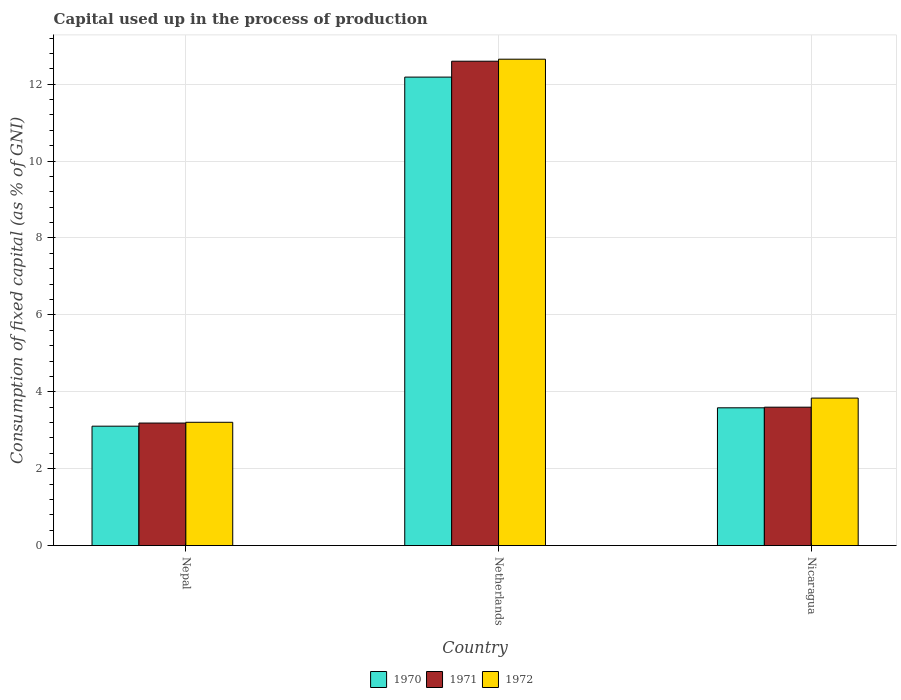How many different coloured bars are there?
Your answer should be compact. 3. How many bars are there on the 3rd tick from the left?
Ensure brevity in your answer.  3. How many bars are there on the 3rd tick from the right?
Provide a succinct answer. 3. What is the label of the 3rd group of bars from the left?
Offer a terse response. Nicaragua. What is the capital used up in the process of production in 1971 in Nicaragua?
Offer a very short reply. 3.6. Across all countries, what is the maximum capital used up in the process of production in 1971?
Make the answer very short. 12.6. Across all countries, what is the minimum capital used up in the process of production in 1971?
Your response must be concise. 3.19. In which country was the capital used up in the process of production in 1972 minimum?
Your answer should be compact. Nepal. What is the total capital used up in the process of production in 1970 in the graph?
Ensure brevity in your answer.  18.87. What is the difference between the capital used up in the process of production in 1971 in Netherlands and that in Nicaragua?
Make the answer very short. 9. What is the difference between the capital used up in the process of production in 1970 in Nepal and the capital used up in the process of production in 1971 in Netherlands?
Ensure brevity in your answer.  -9.49. What is the average capital used up in the process of production in 1971 per country?
Offer a terse response. 6.46. What is the difference between the capital used up in the process of production of/in 1970 and capital used up in the process of production of/in 1971 in Nicaragua?
Your response must be concise. -0.02. What is the ratio of the capital used up in the process of production in 1970 in Netherlands to that in Nicaragua?
Give a very brief answer. 3.4. Is the capital used up in the process of production in 1970 in Netherlands less than that in Nicaragua?
Offer a very short reply. No. Is the difference between the capital used up in the process of production in 1970 in Nepal and Netherlands greater than the difference between the capital used up in the process of production in 1971 in Nepal and Netherlands?
Make the answer very short. Yes. What is the difference between the highest and the second highest capital used up in the process of production in 1972?
Offer a terse response. -0.63. What is the difference between the highest and the lowest capital used up in the process of production in 1971?
Your answer should be very brief. 9.41. In how many countries, is the capital used up in the process of production in 1970 greater than the average capital used up in the process of production in 1970 taken over all countries?
Your answer should be very brief. 1. Is it the case that in every country, the sum of the capital used up in the process of production in 1971 and capital used up in the process of production in 1970 is greater than the capital used up in the process of production in 1972?
Ensure brevity in your answer.  Yes. Are all the bars in the graph horizontal?
Provide a succinct answer. No. How many countries are there in the graph?
Keep it short and to the point. 3. What is the difference between two consecutive major ticks on the Y-axis?
Keep it short and to the point. 2. How many legend labels are there?
Give a very brief answer. 3. What is the title of the graph?
Your answer should be very brief. Capital used up in the process of production. Does "2013" appear as one of the legend labels in the graph?
Provide a short and direct response. No. What is the label or title of the Y-axis?
Your response must be concise. Consumption of fixed capital (as % of GNI). What is the Consumption of fixed capital (as % of GNI) in 1970 in Nepal?
Ensure brevity in your answer.  3.1. What is the Consumption of fixed capital (as % of GNI) in 1971 in Nepal?
Make the answer very short. 3.19. What is the Consumption of fixed capital (as % of GNI) in 1972 in Nepal?
Your response must be concise. 3.21. What is the Consumption of fixed capital (as % of GNI) in 1970 in Netherlands?
Offer a very short reply. 12.18. What is the Consumption of fixed capital (as % of GNI) of 1971 in Netherlands?
Make the answer very short. 12.6. What is the Consumption of fixed capital (as % of GNI) in 1972 in Netherlands?
Ensure brevity in your answer.  12.65. What is the Consumption of fixed capital (as % of GNI) of 1970 in Nicaragua?
Provide a short and direct response. 3.58. What is the Consumption of fixed capital (as % of GNI) of 1971 in Nicaragua?
Provide a succinct answer. 3.6. What is the Consumption of fixed capital (as % of GNI) in 1972 in Nicaragua?
Your answer should be very brief. 3.84. Across all countries, what is the maximum Consumption of fixed capital (as % of GNI) in 1970?
Offer a very short reply. 12.18. Across all countries, what is the maximum Consumption of fixed capital (as % of GNI) of 1971?
Provide a succinct answer. 12.6. Across all countries, what is the maximum Consumption of fixed capital (as % of GNI) of 1972?
Provide a short and direct response. 12.65. Across all countries, what is the minimum Consumption of fixed capital (as % of GNI) in 1970?
Provide a short and direct response. 3.1. Across all countries, what is the minimum Consumption of fixed capital (as % of GNI) of 1971?
Ensure brevity in your answer.  3.19. Across all countries, what is the minimum Consumption of fixed capital (as % of GNI) of 1972?
Offer a terse response. 3.21. What is the total Consumption of fixed capital (as % of GNI) of 1970 in the graph?
Provide a short and direct response. 18.87. What is the total Consumption of fixed capital (as % of GNI) in 1971 in the graph?
Your response must be concise. 19.38. What is the total Consumption of fixed capital (as % of GNI) of 1972 in the graph?
Offer a terse response. 19.69. What is the difference between the Consumption of fixed capital (as % of GNI) in 1970 in Nepal and that in Netherlands?
Provide a short and direct response. -9.08. What is the difference between the Consumption of fixed capital (as % of GNI) in 1971 in Nepal and that in Netherlands?
Offer a very short reply. -9.41. What is the difference between the Consumption of fixed capital (as % of GNI) of 1972 in Nepal and that in Netherlands?
Your answer should be compact. -9.44. What is the difference between the Consumption of fixed capital (as % of GNI) in 1970 in Nepal and that in Nicaragua?
Make the answer very short. -0.48. What is the difference between the Consumption of fixed capital (as % of GNI) of 1971 in Nepal and that in Nicaragua?
Keep it short and to the point. -0.41. What is the difference between the Consumption of fixed capital (as % of GNI) in 1972 in Nepal and that in Nicaragua?
Your response must be concise. -0.63. What is the difference between the Consumption of fixed capital (as % of GNI) in 1970 in Netherlands and that in Nicaragua?
Offer a terse response. 8.6. What is the difference between the Consumption of fixed capital (as % of GNI) in 1971 in Netherlands and that in Nicaragua?
Your answer should be compact. 9. What is the difference between the Consumption of fixed capital (as % of GNI) in 1972 in Netherlands and that in Nicaragua?
Your answer should be very brief. 8.81. What is the difference between the Consumption of fixed capital (as % of GNI) in 1970 in Nepal and the Consumption of fixed capital (as % of GNI) in 1971 in Netherlands?
Provide a short and direct response. -9.49. What is the difference between the Consumption of fixed capital (as % of GNI) in 1970 in Nepal and the Consumption of fixed capital (as % of GNI) in 1972 in Netherlands?
Make the answer very short. -9.54. What is the difference between the Consumption of fixed capital (as % of GNI) of 1971 in Nepal and the Consumption of fixed capital (as % of GNI) of 1972 in Netherlands?
Give a very brief answer. -9.46. What is the difference between the Consumption of fixed capital (as % of GNI) of 1970 in Nepal and the Consumption of fixed capital (as % of GNI) of 1971 in Nicaragua?
Provide a succinct answer. -0.49. What is the difference between the Consumption of fixed capital (as % of GNI) of 1970 in Nepal and the Consumption of fixed capital (as % of GNI) of 1972 in Nicaragua?
Ensure brevity in your answer.  -0.73. What is the difference between the Consumption of fixed capital (as % of GNI) in 1971 in Nepal and the Consumption of fixed capital (as % of GNI) in 1972 in Nicaragua?
Offer a terse response. -0.65. What is the difference between the Consumption of fixed capital (as % of GNI) in 1970 in Netherlands and the Consumption of fixed capital (as % of GNI) in 1971 in Nicaragua?
Offer a terse response. 8.58. What is the difference between the Consumption of fixed capital (as % of GNI) of 1970 in Netherlands and the Consumption of fixed capital (as % of GNI) of 1972 in Nicaragua?
Ensure brevity in your answer.  8.35. What is the difference between the Consumption of fixed capital (as % of GNI) of 1971 in Netherlands and the Consumption of fixed capital (as % of GNI) of 1972 in Nicaragua?
Keep it short and to the point. 8.76. What is the average Consumption of fixed capital (as % of GNI) in 1970 per country?
Make the answer very short. 6.29. What is the average Consumption of fixed capital (as % of GNI) in 1971 per country?
Your response must be concise. 6.46. What is the average Consumption of fixed capital (as % of GNI) in 1972 per country?
Offer a very short reply. 6.56. What is the difference between the Consumption of fixed capital (as % of GNI) of 1970 and Consumption of fixed capital (as % of GNI) of 1971 in Nepal?
Your answer should be compact. -0.08. What is the difference between the Consumption of fixed capital (as % of GNI) of 1970 and Consumption of fixed capital (as % of GNI) of 1972 in Nepal?
Your answer should be very brief. -0.1. What is the difference between the Consumption of fixed capital (as % of GNI) in 1971 and Consumption of fixed capital (as % of GNI) in 1972 in Nepal?
Provide a short and direct response. -0.02. What is the difference between the Consumption of fixed capital (as % of GNI) of 1970 and Consumption of fixed capital (as % of GNI) of 1971 in Netherlands?
Your answer should be very brief. -0.41. What is the difference between the Consumption of fixed capital (as % of GNI) in 1970 and Consumption of fixed capital (as % of GNI) in 1972 in Netherlands?
Your response must be concise. -0.47. What is the difference between the Consumption of fixed capital (as % of GNI) in 1971 and Consumption of fixed capital (as % of GNI) in 1972 in Netherlands?
Your answer should be compact. -0.05. What is the difference between the Consumption of fixed capital (as % of GNI) in 1970 and Consumption of fixed capital (as % of GNI) in 1971 in Nicaragua?
Keep it short and to the point. -0.02. What is the difference between the Consumption of fixed capital (as % of GNI) in 1970 and Consumption of fixed capital (as % of GNI) in 1972 in Nicaragua?
Provide a short and direct response. -0.25. What is the difference between the Consumption of fixed capital (as % of GNI) in 1971 and Consumption of fixed capital (as % of GNI) in 1972 in Nicaragua?
Your response must be concise. -0.24. What is the ratio of the Consumption of fixed capital (as % of GNI) in 1970 in Nepal to that in Netherlands?
Provide a succinct answer. 0.25. What is the ratio of the Consumption of fixed capital (as % of GNI) in 1971 in Nepal to that in Netherlands?
Ensure brevity in your answer.  0.25. What is the ratio of the Consumption of fixed capital (as % of GNI) in 1972 in Nepal to that in Netherlands?
Keep it short and to the point. 0.25. What is the ratio of the Consumption of fixed capital (as % of GNI) in 1970 in Nepal to that in Nicaragua?
Make the answer very short. 0.87. What is the ratio of the Consumption of fixed capital (as % of GNI) of 1971 in Nepal to that in Nicaragua?
Provide a short and direct response. 0.89. What is the ratio of the Consumption of fixed capital (as % of GNI) of 1972 in Nepal to that in Nicaragua?
Ensure brevity in your answer.  0.84. What is the ratio of the Consumption of fixed capital (as % of GNI) in 1970 in Netherlands to that in Nicaragua?
Provide a succinct answer. 3.4. What is the ratio of the Consumption of fixed capital (as % of GNI) of 1971 in Netherlands to that in Nicaragua?
Give a very brief answer. 3.5. What is the ratio of the Consumption of fixed capital (as % of GNI) in 1972 in Netherlands to that in Nicaragua?
Provide a short and direct response. 3.3. What is the difference between the highest and the second highest Consumption of fixed capital (as % of GNI) in 1970?
Keep it short and to the point. 8.6. What is the difference between the highest and the second highest Consumption of fixed capital (as % of GNI) in 1971?
Make the answer very short. 9. What is the difference between the highest and the second highest Consumption of fixed capital (as % of GNI) of 1972?
Provide a short and direct response. 8.81. What is the difference between the highest and the lowest Consumption of fixed capital (as % of GNI) of 1970?
Provide a short and direct response. 9.08. What is the difference between the highest and the lowest Consumption of fixed capital (as % of GNI) in 1971?
Ensure brevity in your answer.  9.41. What is the difference between the highest and the lowest Consumption of fixed capital (as % of GNI) in 1972?
Provide a short and direct response. 9.44. 